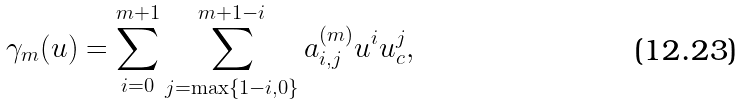Convert formula to latex. <formula><loc_0><loc_0><loc_500><loc_500>\gamma _ { m } ( u ) = \sum _ { i = 0 } ^ { m + 1 } \sum _ { j = \max \{ 1 - i , 0 \} } ^ { m + 1 - i } a _ { i , j } ^ { ( m ) } u ^ { i } u _ { c } ^ { j } ,</formula> 